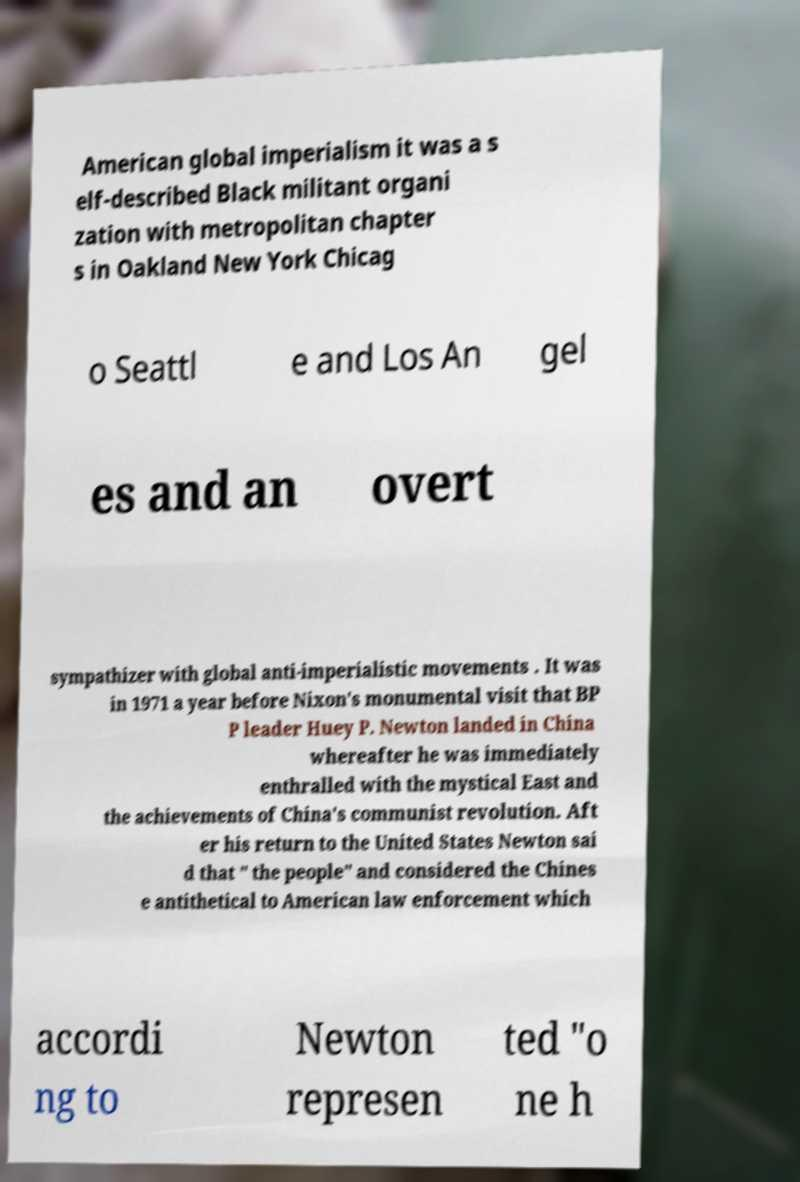I need the written content from this picture converted into text. Can you do that? American global imperialism it was a s elf-described Black militant organi zation with metropolitan chapter s in Oakland New York Chicag o Seattl e and Los An gel es and an overt sympathizer with global anti-imperialistic movements . It was in 1971 a year before Nixon's monumental visit that BP P leader Huey P. Newton landed in China whereafter he was immediately enthralled with the mystical East and the achievements of China's communist revolution. Aft er his return to the United States Newton sai d that " the people" and considered the Chines e antithetical to American law enforcement which accordi ng to Newton represen ted "o ne h 